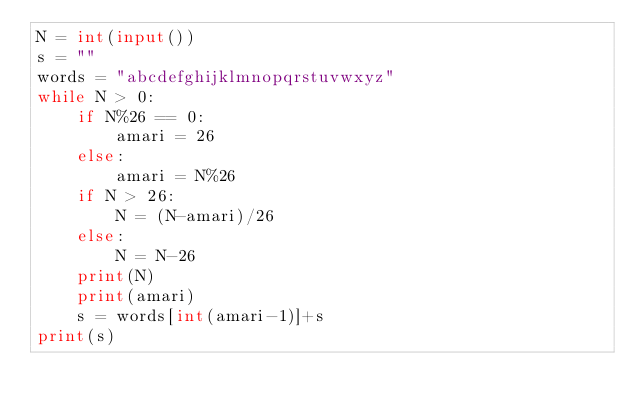<code> <loc_0><loc_0><loc_500><loc_500><_Python_>N = int(input())
s = ""
words = "abcdefghijklmnopqrstuvwxyz"
while N > 0:
    if N%26 == 0:
        amari = 26
    else:
        amari = N%26
    if N > 26:
        N = (N-amari)/26
    else:
        N = N-26
    print(N)
    print(amari)
    s = words[int(amari-1)]+s
print(s)</code> 